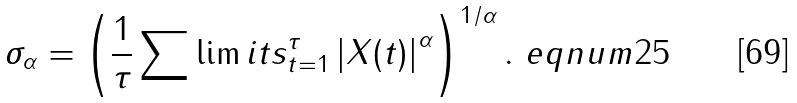Convert formula to latex. <formula><loc_0><loc_0><loc_500><loc_500>\sigma _ { \alpha } = \left ( \frac { 1 } { \tau } \sum \lim i t s _ { t = 1 } ^ { \tau } \left | X ( t ) \right | ^ { \alpha } \right ) ^ { 1 / \alpha } . \ e q n u m { 2 5 }</formula> 